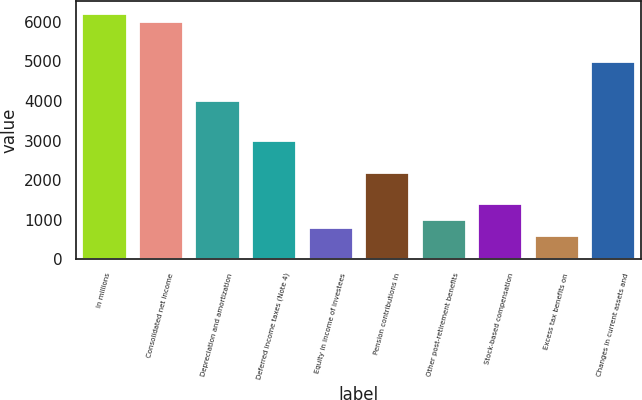Convert chart. <chart><loc_0><loc_0><loc_500><loc_500><bar_chart><fcel>In millions<fcel>Consolidated net income<fcel>Depreciation and amortization<fcel>Deferred income taxes (Note 4)<fcel>Equity in income of investees<fcel>Pension contributions in<fcel>Other post-retirement benefits<fcel>Stock-based compensation<fcel>Excess tax benefits on<fcel>Changes in current assets and<nl><fcel>6214.1<fcel>6014<fcel>4013<fcel>3012.5<fcel>811.4<fcel>2212.1<fcel>1011.5<fcel>1411.7<fcel>611.3<fcel>5013.5<nl></chart> 